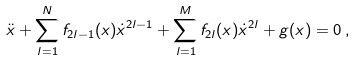Convert formula to latex. <formula><loc_0><loc_0><loc_500><loc_500>\ddot { x } + \sum _ { l = 1 } ^ { N } f _ { 2 l - 1 } ( x ) \dot { x } ^ { 2 l - 1 } + \sum _ { l = 1 } ^ { M } f _ { 2 l } ( x ) \dot { x } ^ { 2 l } + g ( x ) = 0 \, ,</formula> 